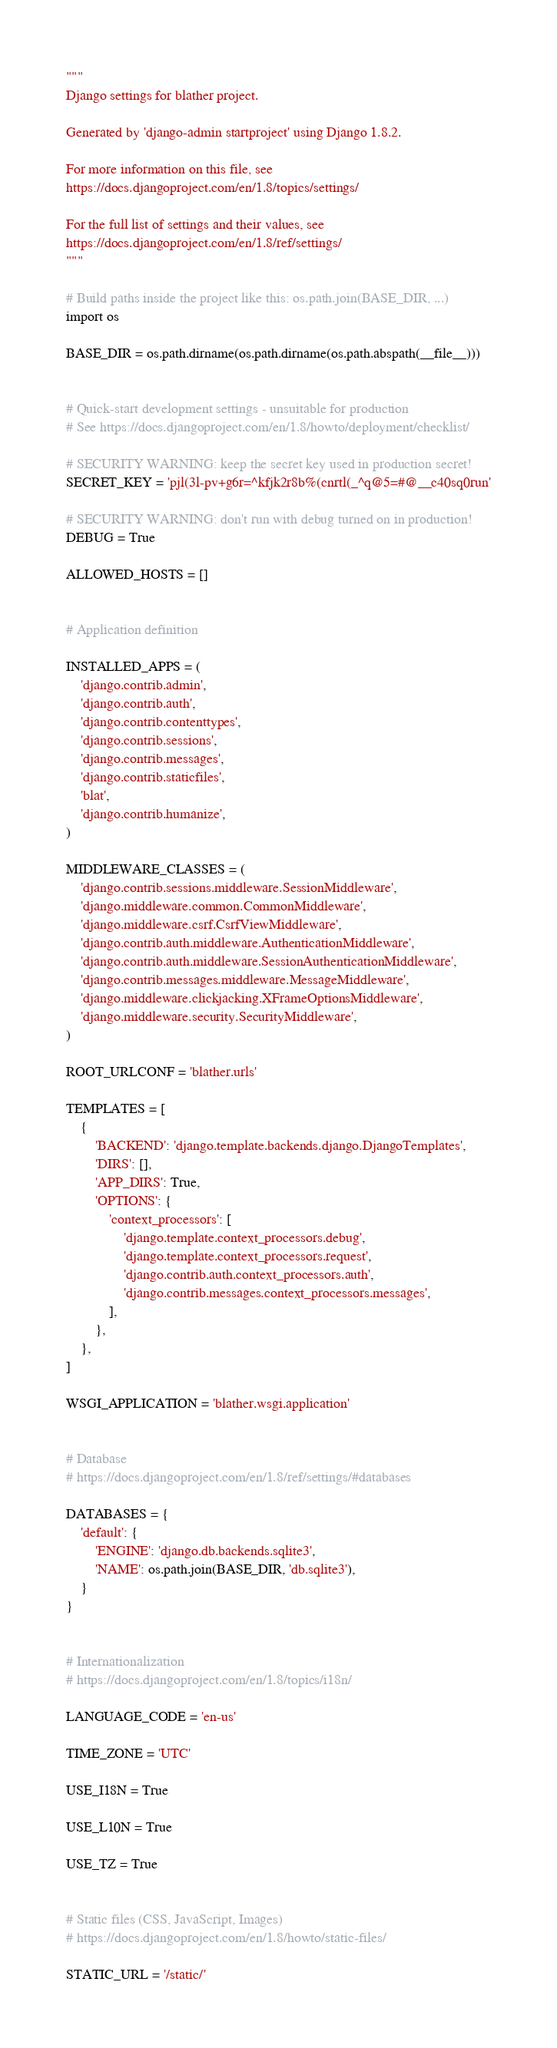<code> <loc_0><loc_0><loc_500><loc_500><_Python_>"""
Django settings for blather project.

Generated by 'django-admin startproject' using Django 1.8.2.

For more information on this file, see
https://docs.djangoproject.com/en/1.8/topics/settings/

For the full list of settings and their values, see
https://docs.djangoproject.com/en/1.8/ref/settings/
"""

# Build paths inside the project like this: os.path.join(BASE_DIR, ...)
import os

BASE_DIR = os.path.dirname(os.path.dirname(os.path.abspath(__file__)))


# Quick-start development settings - unsuitable for production
# See https://docs.djangoproject.com/en/1.8/howto/deployment/checklist/

# SECURITY WARNING: keep the secret key used in production secret!
SECRET_KEY = 'pjl(3l-pv+g6r=^kfjk2r8b%(cnrtl(_^q@5=#@__c40sq0run'

# SECURITY WARNING: don't run with debug turned on in production!
DEBUG = True

ALLOWED_HOSTS = []


# Application definition

INSTALLED_APPS = (
    'django.contrib.admin',
    'django.contrib.auth',
    'django.contrib.contenttypes',
    'django.contrib.sessions',
    'django.contrib.messages',
    'django.contrib.staticfiles',
    'blat',
    'django.contrib.humanize',
)

MIDDLEWARE_CLASSES = (
    'django.contrib.sessions.middleware.SessionMiddleware',
    'django.middleware.common.CommonMiddleware',
    'django.middleware.csrf.CsrfViewMiddleware',
    'django.contrib.auth.middleware.AuthenticationMiddleware',
    'django.contrib.auth.middleware.SessionAuthenticationMiddleware',
    'django.contrib.messages.middleware.MessageMiddleware',
    'django.middleware.clickjacking.XFrameOptionsMiddleware',
    'django.middleware.security.SecurityMiddleware',
)

ROOT_URLCONF = 'blather.urls'

TEMPLATES = [
    {
        'BACKEND': 'django.template.backends.django.DjangoTemplates',
        'DIRS': [],
        'APP_DIRS': True,
        'OPTIONS': {
            'context_processors': [
                'django.template.context_processors.debug',
                'django.template.context_processors.request',
                'django.contrib.auth.context_processors.auth',
                'django.contrib.messages.context_processors.messages',
            ],
        },
    },
]

WSGI_APPLICATION = 'blather.wsgi.application'


# Database
# https://docs.djangoproject.com/en/1.8/ref/settings/#databases

DATABASES = {
    'default': {
        'ENGINE': 'django.db.backends.sqlite3',
        'NAME': os.path.join(BASE_DIR, 'db.sqlite3'),
    }
}


# Internationalization
# https://docs.djangoproject.com/en/1.8/topics/i18n/

LANGUAGE_CODE = 'en-us'

TIME_ZONE = 'UTC'

USE_I18N = True

USE_L10N = True

USE_TZ = True


# Static files (CSS, JavaScript, Images)
# https://docs.djangoproject.com/en/1.8/howto/static-files/

STATIC_URL = '/static/'
</code> 